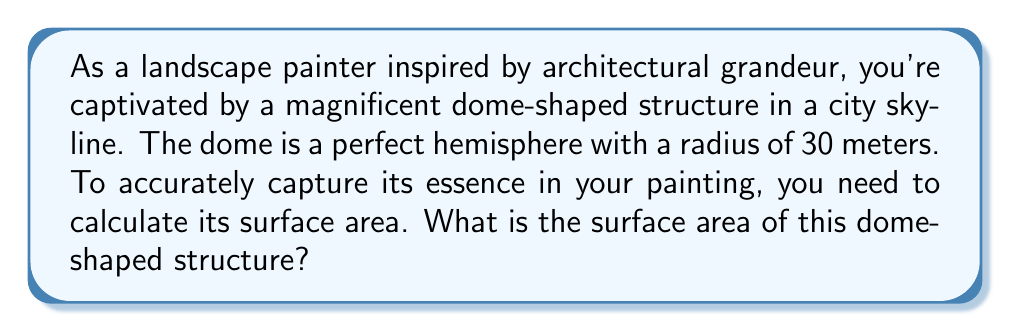Can you answer this question? To find the surface area of a dome-shaped structure that is a perfect hemisphere, we need to use the formula for the surface area of a sphere and divide it by 2. Here's the step-by-step process:

1) The formula for the surface area of a sphere is:
   $$A = 4\pi r^2$$
   where $A$ is the surface area and $r$ is the radius.

2) Since our dome is a hemisphere (half of a sphere), we need to divide this formula by 2:
   $$A_{dome} = \frac{1}{2} \cdot 4\pi r^2 = 2\pi r^2$$

3) We're given that the radius of the dome is 30 meters. Let's substitute this into our formula:
   $$A_{dome} = 2\pi (30)^2$$

4) Now let's calculate:
   $$A_{dome} = 2\pi \cdot 900 = 1800\pi$$

5) If we want to express this in square meters, we can calculate the approximate value:
   $$A_{dome} \approx 1800 \cdot 3.14159 \approx 5654.86 \text{ m}^2$$

Thus, the surface area of the dome is $1800\pi$ square meters, or approximately 5654.86 square meters.
Answer: $1800\pi \text{ m}^2$ or approximately $5654.86 \text{ m}^2$ 